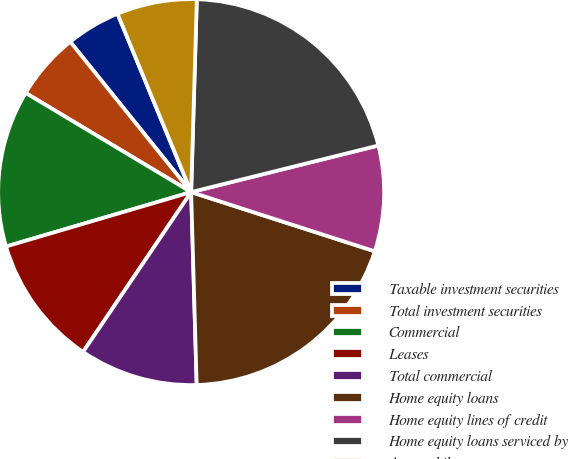Convert chart. <chart><loc_0><loc_0><loc_500><loc_500><pie_chart><fcel>Taxable investment securities<fcel>Total investment securities<fcel>Commercial<fcel>Leases<fcel>Total commercial<fcel>Home equity loans<fcel>Home equity lines of credit<fcel>Home equity loans serviced by<fcel>Automobile<nl><fcel>4.55%<fcel>5.63%<fcel>13.14%<fcel>10.99%<fcel>9.92%<fcel>19.58%<fcel>8.85%<fcel>20.65%<fcel>6.7%<nl></chart> 